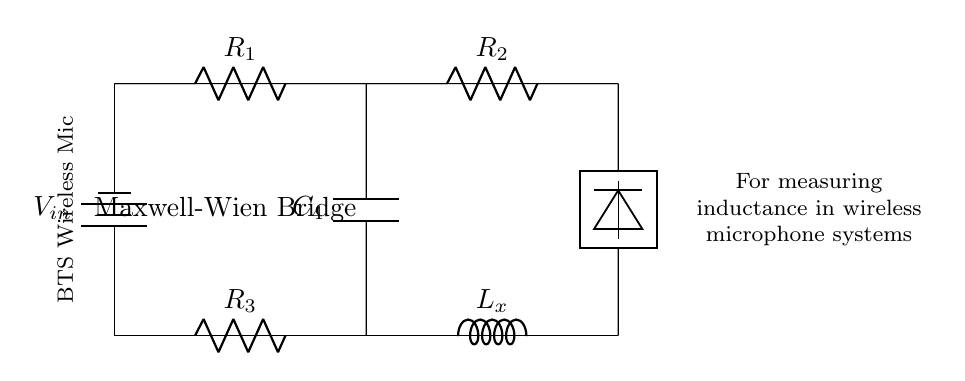What is the input voltage in the circuit? The input voltage is denoted by V_in, which is indicated on the battery symbol in the circuit.
Answer: V_in What components are in the Maxwell-Wien Bridge? The components include resistors R_1, R_2, R_3, an inductor L_x, and a capacitor C_4.
Answer: R_1, R_2, R_3, L_x, C_4 Which component is used to measure inductance? The component used to measure inductance is L_x, represented as the inductor in the diagram.
Answer: L_x How many resistors are present in the Bridge circuit? There are three resistors present: R_1, R_2, and R_3, which are identified in the circuit.
Answer: 3 How does the capacitor interact with the other components? The capacitor C_4 connects the upper and lower branches of the bridge, affecting the balance of the circuit and its overall impedance.
Answer: It connects upper and lower branches What is the purpose of this Maxwell-Wien Bridge circuit? The purpose is to measure inductance specifically in wireless microphone systems, as described in the circuit label.
Answer: To measure inductance in wireless microphone systems What does the detector do in the circuit? The detector measures the potential difference across the bridge and helps to determine the balance condition for accurate inductance measurement.
Answer: Measures potential difference 